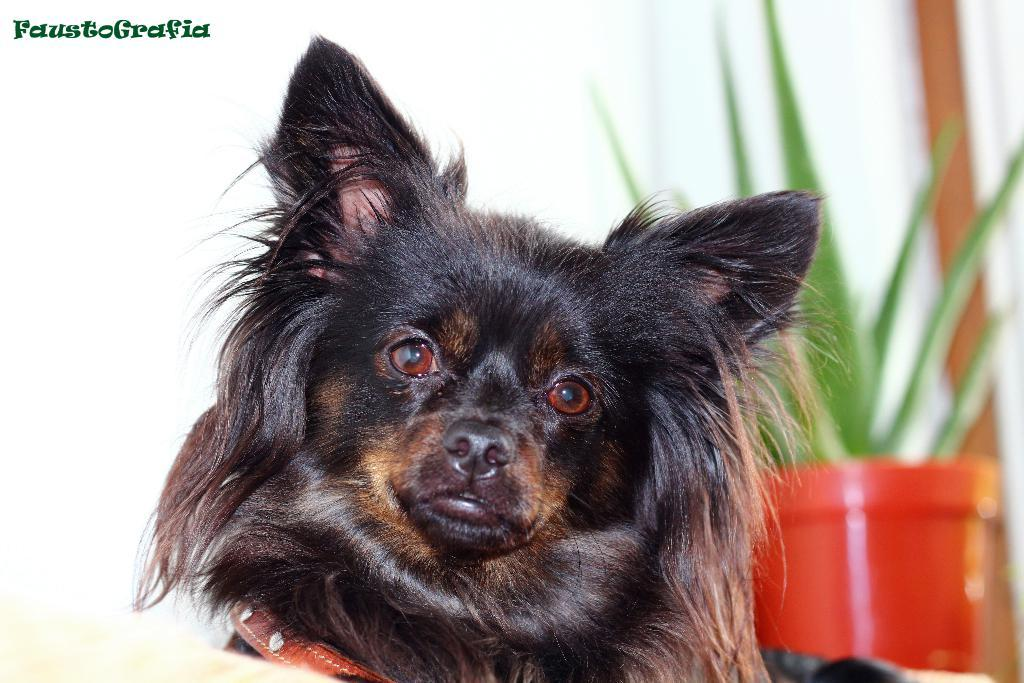What type of animal is in the image? There is a dog in the image. What can be seen in the background of the image? There is a plant pot in the background of the image. Is there any text or logo visible in the image? Yes, there is a watermark in the image. Can you see any cherries on the dog in the image? There are no cherries present in the image, and the dog does not have any cherries on it. Is there a tiger visible in the image? No, there is no tiger present in the image; it features a dog. 